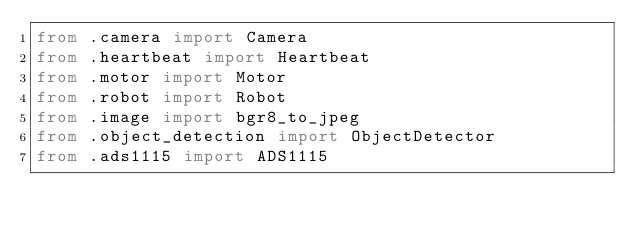<code> <loc_0><loc_0><loc_500><loc_500><_Python_>from .camera import Camera
from .heartbeat import Heartbeat
from .motor import Motor
from .robot import Robot
from .image import bgr8_to_jpeg
from .object_detection import ObjectDetector
from .ads1115 import ADS1115
</code> 